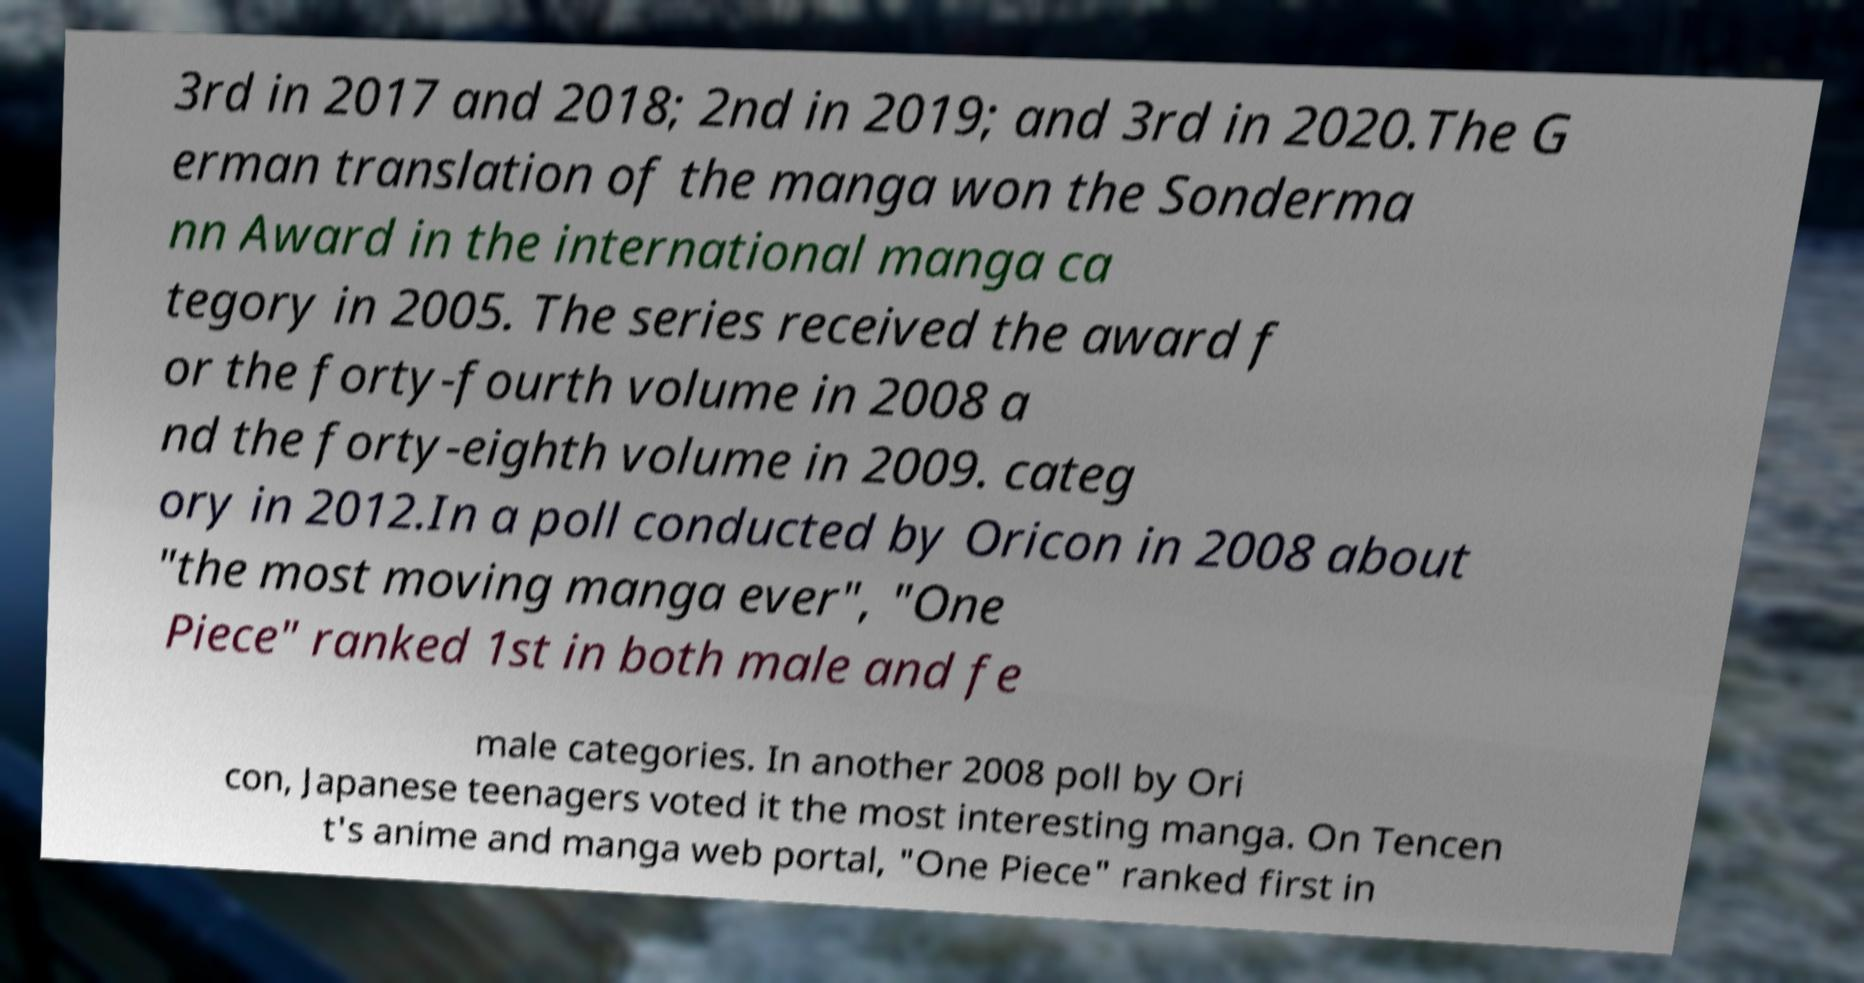For documentation purposes, I need the text within this image transcribed. Could you provide that? 3rd in 2017 and 2018; 2nd in 2019; and 3rd in 2020.The G erman translation of the manga won the Sonderma nn Award in the international manga ca tegory in 2005. The series received the award f or the forty-fourth volume in 2008 a nd the forty-eighth volume in 2009. categ ory in 2012.In a poll conducted by Oricon in 2008 about "the most moving manga ever", "One Piece" ranked 1st in both male and fe male categories. In another 2008 poll by Ori con, Japanese teenagers voted it the most interesting manga. On Tencen t's anime and manga web portal, "One Piece" ranked first in 